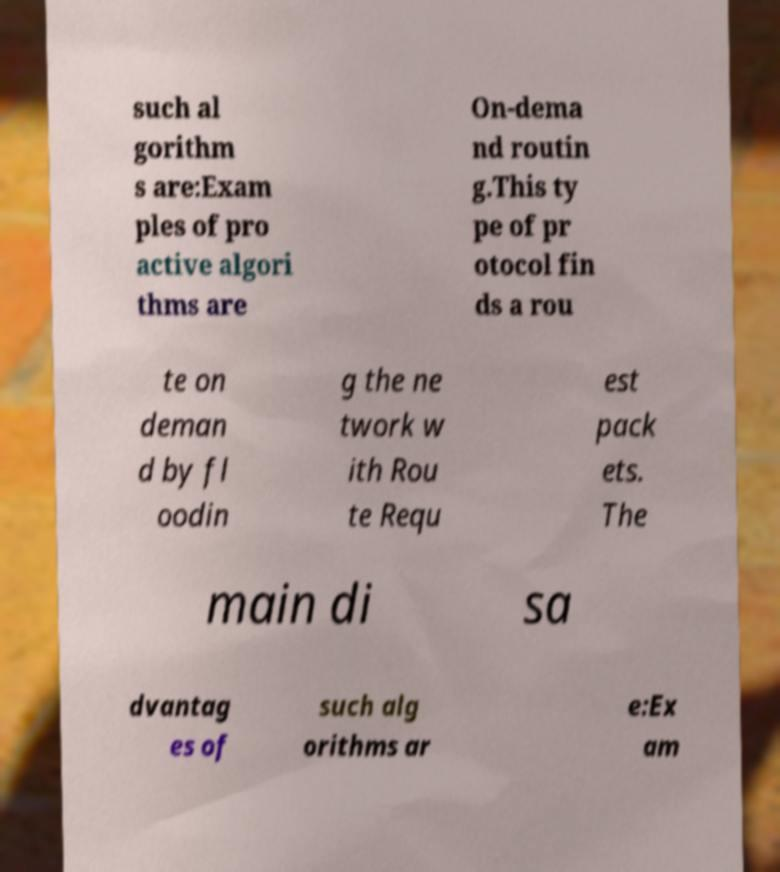Could you assist in decoding the text presented in this image and type it out clearly? such al gorithm s are:Exam ples of pro active algori thms are On-dema nd routin g.This ty pe of pr otocol fin ds a rou te on deman d by fl oodin g the ne twork w ith Rou te Requ est pack ets. The main di sa dvantag es of such alg orithms ar e:Ex am 